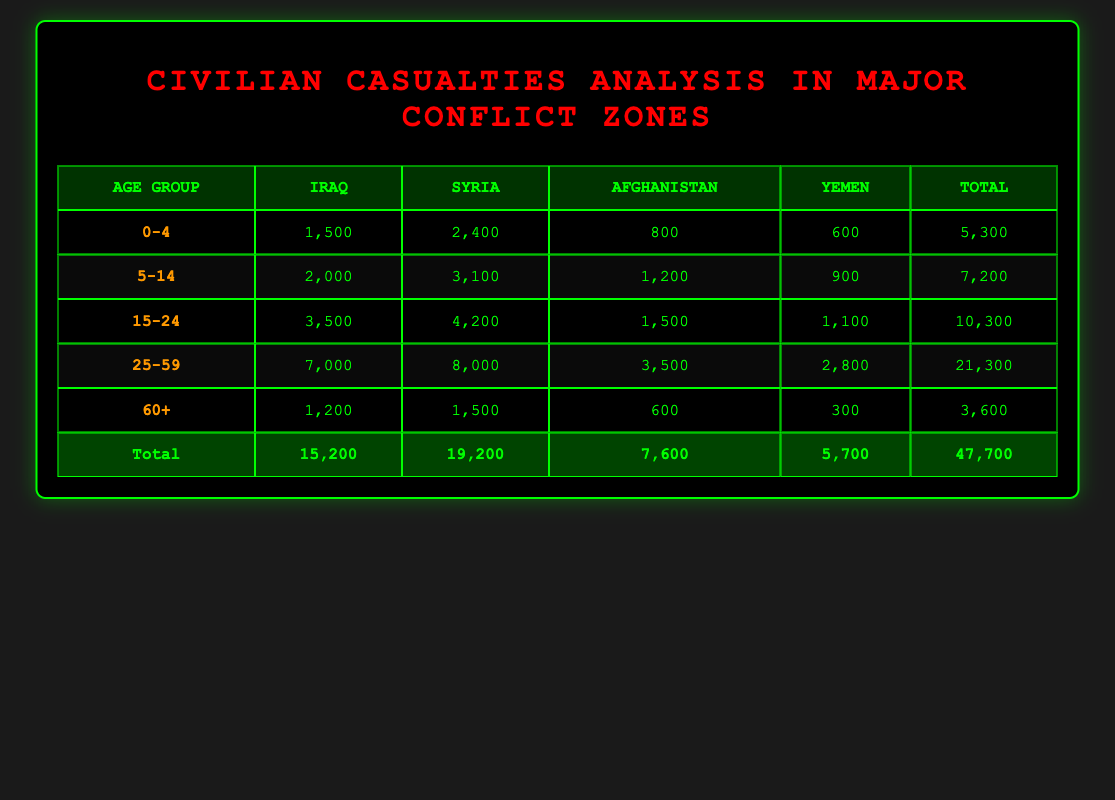What is the total number of civilian casualties in Yemen? From the table, the total number of casualties in Yemen is listed as 5,700. This figure is obtained from the last row in the table, which sums up all age group casualties in Yemen.
Answer: 5,700 Which age group has the highest number of casualties in Syria? In the table, the age group 25-59 has 8,000 casualties, which is the highest among the listed age groups for Syria when comparing the values in that column.
Answer: 25-59 How many casualties are there for the age group 15-24 in all listed countries combined? To find the total casualties for the age group 15-24, we sum the individual casualties from each country: 3,500 (Iraq) + 4,200 (Syria) + 1,500 (Afghanistan) + 1,100 (Yemen) = 10,300. Therefore, the total for this age group is 10,300.
Answer: 10,300 Is the number of casualties for the age group 60+ greater in Iraq than in Afghanistan? The table shows 1,200 casualties for Iraq in the 60+ age group and 600 for Afghanistan. Since 1,200 is greater than 600, the statement is true.
Answer: Yes What is the average number of civilian casualties for the 0-4 age group across all countries? The total casualties for the 0-4 age group are 1,500 (Iraq) + 2,400 (Syria) + 800 (Afghanistan) + 600 (Yemen) = 5,300. Since there are 4 countries, we calculate the average by dividing 5,300 by 4, which equals 1,325.
Answer: 1,325 Which age group has the lowest total casualties across all countries? By reviewing the total casualties per age group from the table, we see the age group 60+ has 3,600 total casualties, which is the lowest compared to other age groups: 0-4 (5,300), 5-14 (7,200), 15-24 (10,300), and 25-59 (21,300).
Answer: 60+ What are the total casualties for the age group 25-59 in Iraq and Yemen combined? From the table, the casualties for age group 25-59 in Iraq are 7,000 and in Yemen are 2,800. To find the combination, we sum these values: 7,000 (Iraq) + 2,800 (Yemen) = 9,800. Thus, the total is 9,800.
Answer: 9,800 Are there more civilian casualties in the age group 5-14 than in the age group 60+ for Syria? The table shows that the number of casualties in Syria for age group 5-14 is 3,100, while for age group 60+ it is 1,500. Since 3,100 is greater than 1,500, the statement is true.
Answer: Yes 